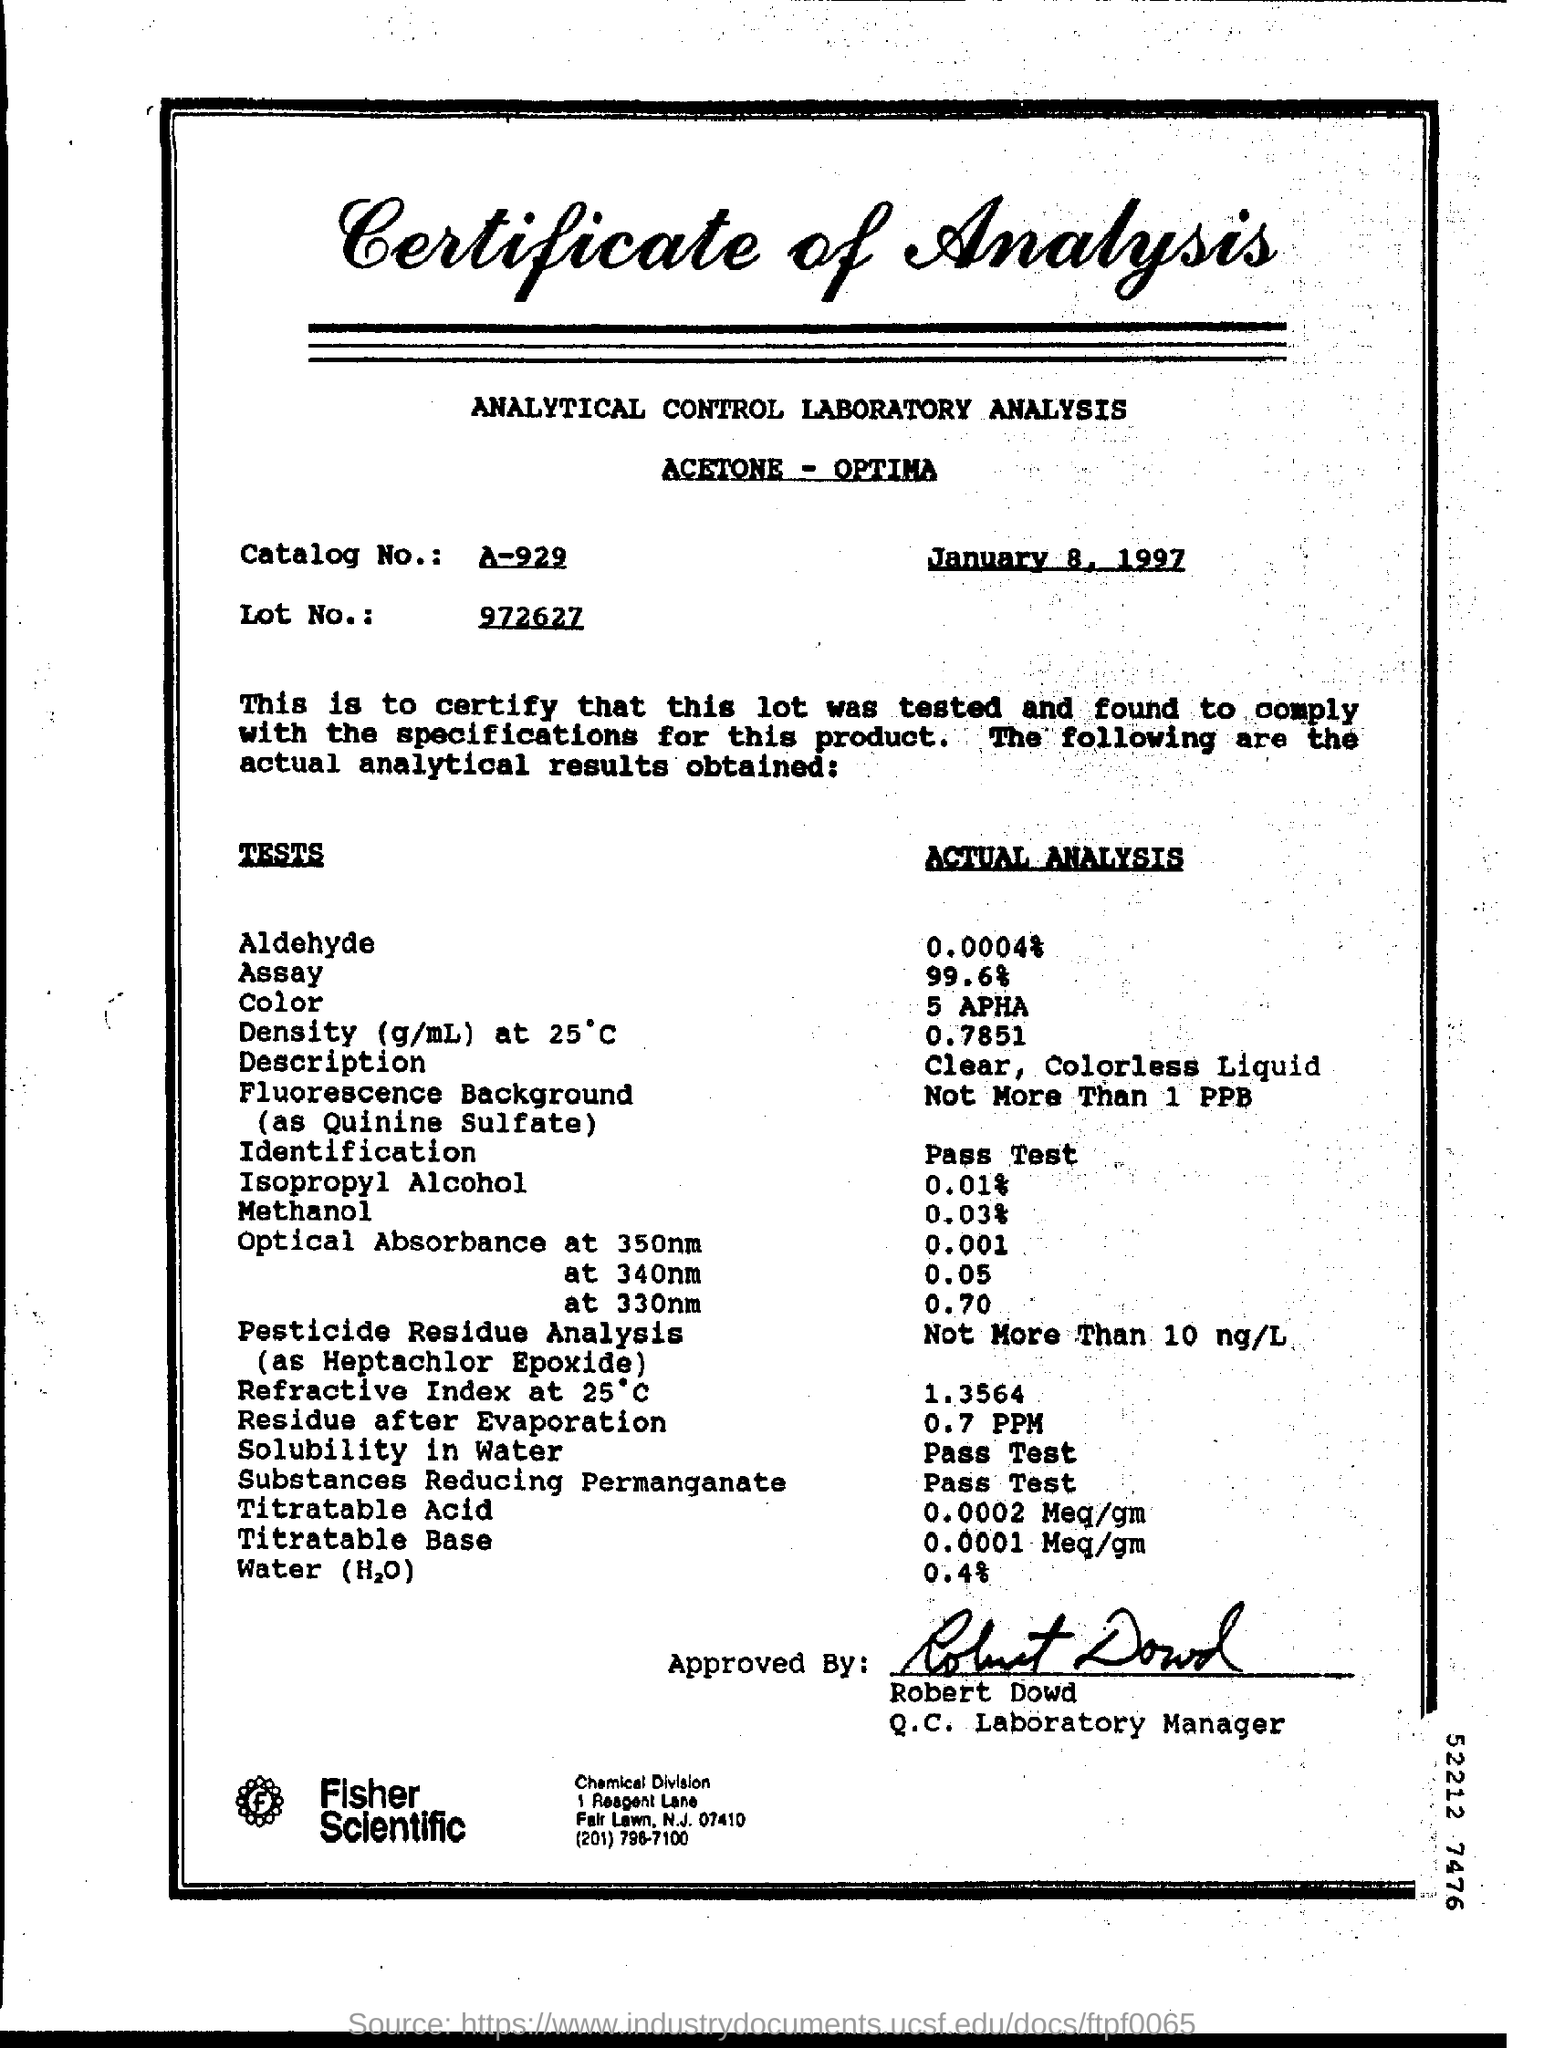List a handful of essential elements in this visual. The actual analysis for methanol is 0.03%. The title of the document is a Certificate of Analysis. The date at the top of the document is January 8, 1997. The solubility of a substance in water has been analyzed and found to pass the test. The individual known as Robert Dowd is the Manager of the Q.C. Laboratory. 